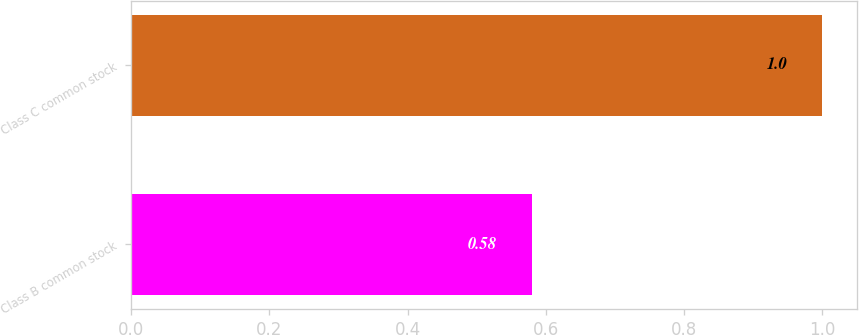Convert chart. <chart><loc_0><loc_0><loc_500><loc_500><bar_chart><fcel>Class B common stock<fcel>Class C common stock<nl><fcel>0.58<fcel>1<nl></chart> 